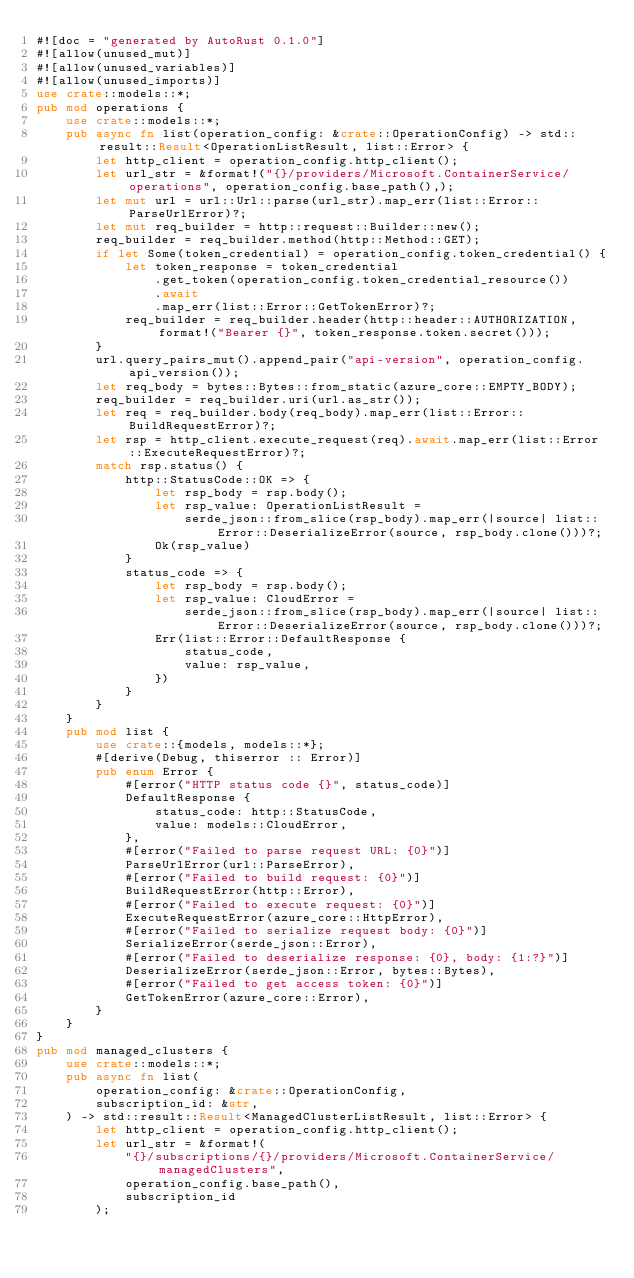Convert code to text. <code><loc_0><loc_0><loc_500><loc_500><_Rust_>#![doc = "generated by AutoRust 0.1.0"]
#![allow(unused_mut)]
#![allow(unused_variables)]
#![allow(unused_imports)]
use crate::models::*;
pub mod operations {
    use crate::models::*;
    pub async fn list(operation_config: &crate::OperationConfig) -> std::result::Result<OperationListResult, list::Error> {
        let http_client = operation_config.http_client();
        let url_str = &format!("{}/providers/Microsoft.ContainerService/operations", operation_config.base_path(),);
        let mut url = url::Url::parse(url_str).map_err(list::Error::ParseUrlError)?;
        let mut req_builder = http::request::Builder::new();
        req_builder = req_builder.method(http::Method::GET);
        if let Some(token_credential) = operation_config.token_credential() {
            let token_response = token_credential
                .get_token(operation_config.token_credential_resource())
                .await
                .map_err(list::Error::GetTokenError)?;
            req_builder = req_builder.header(http::header::AUTHORIZATION, format!("Bearer {}", token_response.token.secret()));
        }
        url.query_pairs_mut().append_pair("api-version", operation_config.api_version());
        let req_body = bytes::Bytes::from_static(azure_core::EMPTY_BODY);
        req_builder = req_builder.uri(url.as_str());
        let req = req_builder.body(req_body).map_err(list::Error::BuildRequestError)?;
        let rsp = http_client.execute_request(req).await.map_err(list::Error::ExecuteRequestError)?;
        match rsp.status() {
            http::StatusCode::OK => {
                let rsp_body = rsp.body();
                let rsp_value: OperationListResult =
                    serde_json::from_slice(rsp_body).map_err(|source| list::Error::DeserializeError(source, rsp_body.clone()))?;
                Ok(rsp_value)
            }
            status_code => {
                let rsp_body = rsp.body();
                let rsp_value: CloudError =
                    serde_json::from_slice(rsp_body).map_err(|source| list::Error::DeserializeError(source, rsp_body.clone()))?;
                Err(list::Error::DefaultResponse {
                    status_code,
                    value: rsp_value,
                })
            }
        }
    }
    pub mod list {
        use crate::{models, models::*};
        #[derive(Debug, thiserror :: Error)]
        pub enum Error {
            #[error("HTTP status code {}", status_code)]
            DefaultResponse {
                status_code: http::StatusCode,
                value: models::CloudError,
            },
            #[error("Failed to parse request URL: {0}")]
            ParseUrlError(url::ParseError),
            #[error("Failed to build request: {0}")]
            BuildRequestError(http::Error),
            #[error("Failed to execute request: {0}")]
            ExecuteRequestError(azure_core::HttpError),
            #[error("Failed to serialize request body: {0}")]
            SerializeError(serde_json::Error),
            #[error("Failed to deserialize response: {0}, body: {1:?}")]
            DeserializeError(serde_json::Error, bytes::Bytes),
            #[error("Failed to get access token: {0}")]
            GetTokenError(azure_core::Error),
        }
    }
}
pub mod managed_clusters {
    use crate::models::*;
    pub async fn list(
        operation_config: &crate::OperationConfig,
        subscription_id: &str,
    ) -> std::result::Result<ManagedClusterListResult, list::Error> {
        let http_client = operation_config.http_client();
        let url_str = &format!(
            "{}/subscriptions/{}/providers/Microsoft.ContainerService/managedClusters",
            operation_config.base_path(),
            subscription_id
        );</code> 